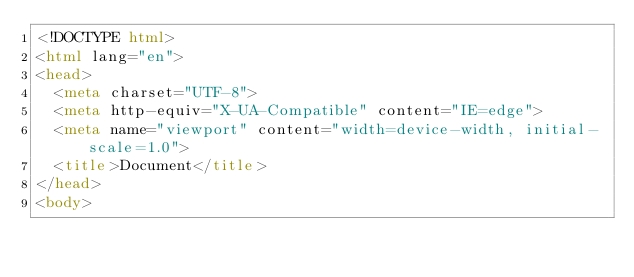<code> <loc_0><loc_0><loc_500><loc_500><_HTML_><!DOCTYPE html>
<html lang="en">
<head>
  <meta charset="UTF-8">
  <meta http-equiv="X-UA-Compatible" content="IE=edge">
  <meta name="viewport" content="width=device-width, initial-scale=1.0">
  <title>Document</title>
</head>
<body></code> 